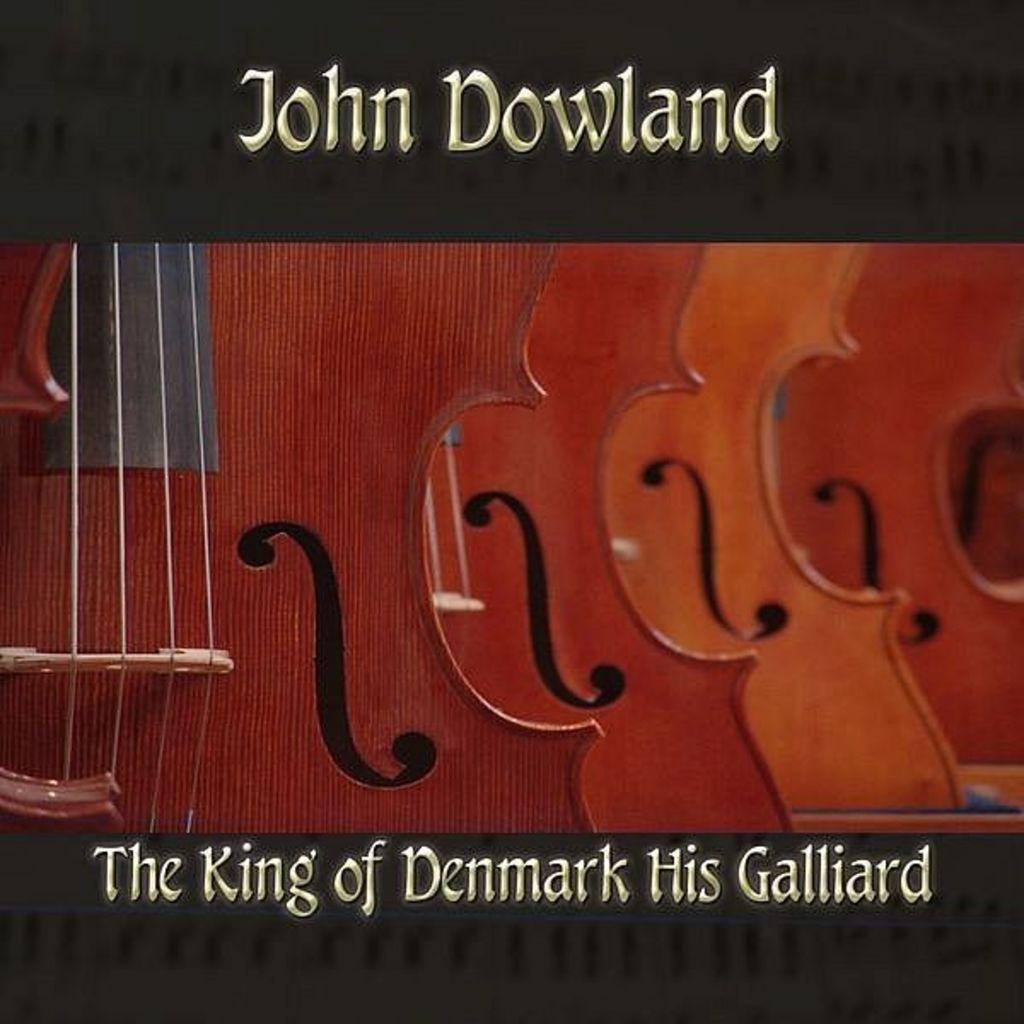How would you summarize this image in a sentence or two? In this image I can see few musical instruments. 